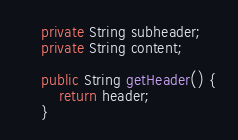Convert code to text. <code><loc_0><loc_0><loc_500><loc_500><_Java_>	private String subheader;
	private String content;

	public String getHeader() {
		return header;
	}</code> 